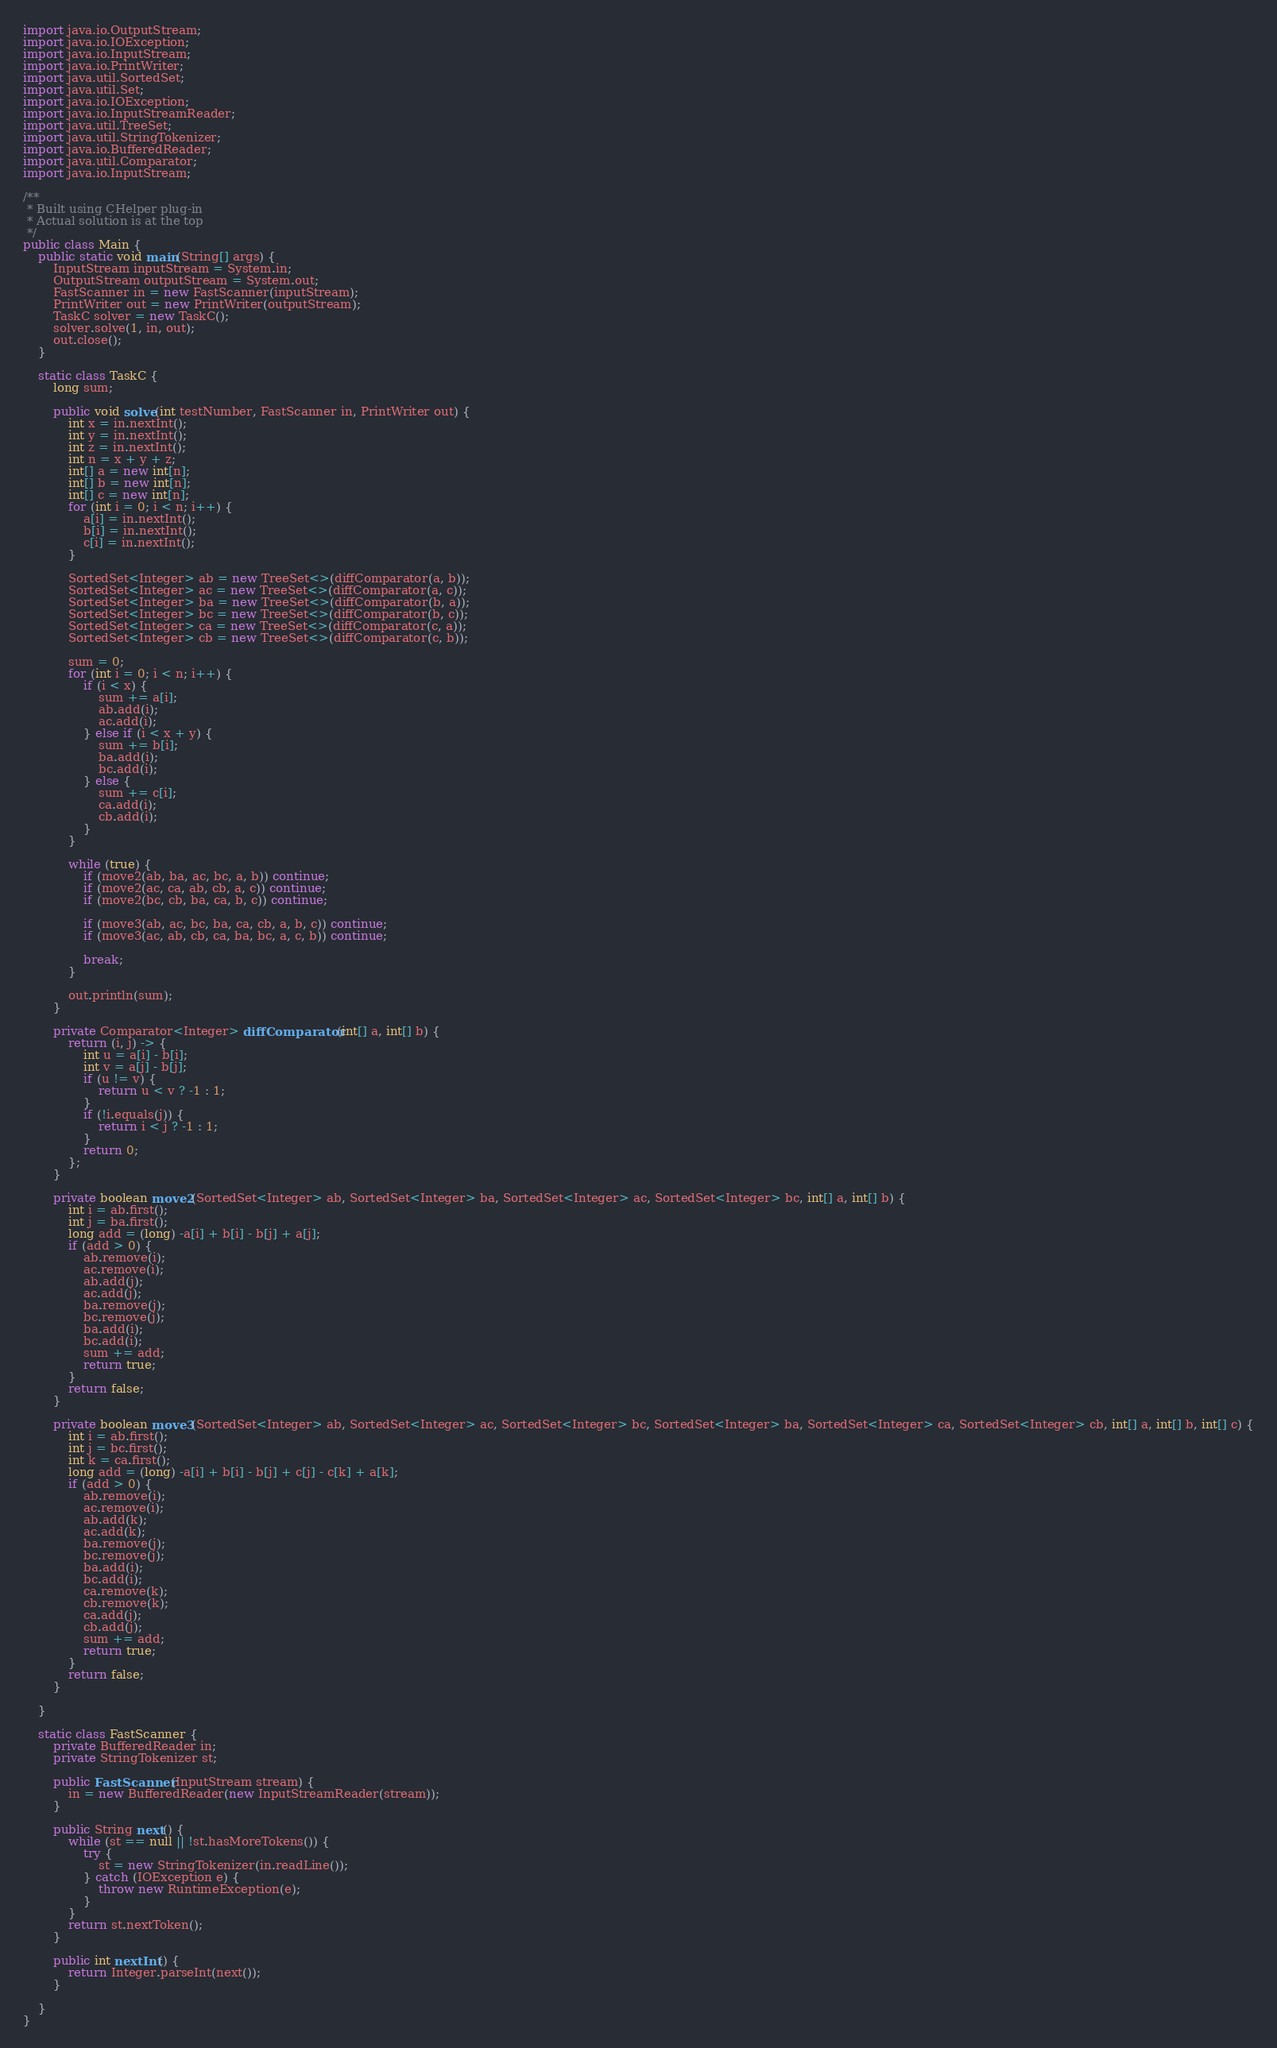<code> <loc_0><loc_0><loc_500><loc_500><_Java_>import java.io.OutputStream;
import java.io.IOException;
import java.io.InputStream;
import java.io.PrintWriter;
import java.util.SortedSet;
import java.util.Set;
import java.io.IOException;
import java.io.InputStreamReader;
import java.util.TreeSet;
import java.util.StringTokenizer;
import java.io.BufferedReader;
import java.util.Comparator;
import java.io.InputStream;

/**
 * Built using CHelper plug-in
 * Actual solution is at the top
 */
public class Main {
	public static void main(String[] args) {
		InputStream inputStream = System.in;
		OutputStream outputStream = System.out;
		FastScanner in = new FastScanner(inputStream);
		PrintWriter out = new PrintWriter(outputStream);
		TaskC solver = new TaskC();
		solver.solve(1, in, out);
		out.close();
	}

	static class TaskC {
		long sum;

		public void solve(int testNumber, FastScanner in, PrintWriter out) {
			int x = in.nextInt();
			int y = in.nextInt();
			int z = in.nextInt();
			int n = x + y + z;
			int[] a = new int[n];
			int[] b = new int[n];
			int[] c = new int[n];
			for (int i = 0; i < n; i++) {
				a[i] = in.nextInt();
				b[i] = in.nextInt();
				c[i] = in.nextInt();
			}

			SortedSet<Integer> ab = new TreeSet<>(diffComparator(a, b));
			SortedSet<Integer> ac = new TreeSet<>(diffComparator(a, c));
			SortedSet<Integer> ba = new TreeSet<>(diffComparator(b, a));
			SortedSet<Integer> bc = new TreeSet<>(diffComparator(b, c));
			SortedSet<Integer> ca = new TreeSet<>(diffComparator(c, a));
			SortedSet<Integer> cb = new TreeSet<>(diffComparator(c, b));

			sum = 0;
			for (int i = 0; i < n; i++) {
				if (i < x) {
					sum += a[i];
					ab.add(i);
					ac.add(i);
				} else if (i < x + y) {
					sum += b[i];
					ba.add(i);
					bc.add(i);
				} else {
					sum += c[i];
					ca.add(i);
					cb.add(i);
				}
			}

			while (true) {
				if (move2(ab, ba, ac, bc, a, b)) continue;
				if (move2(ac, ca, ab, cb, a, c)) continue;
				if (move2(bc, cb, ba, ca, b, c)) continue;

				if (move3(ab, ac, bc, ba, ca, cb, a, b, c)) continue;
				if (move3(ac, ab, cb, ca, ba, bc, a, c, b)) continue;

				break;
			}

			out.println(sum);
		}

		private Comparator<Integer> diffComparator(int[] a, int[] b) {
			return (i, j) -> {
				int u = a[i] - b[i];
				int v = a[j] - b[j];
				if (u != v) {
					return u < v ? -1 : 1;
				}
				if (!i.equals(j)) {
					return i < j ? -1 : 1;
				}
				return 0;
			};
		}

		private boolean move2(SortedSet<Integer> ab, SortedSet<Integer> ba, SortedSet<Integer> ac, SortedSet<Integer> bc, int[] a, int[] b) {
			int i = ab.first();
			int j = ba.first();
			long add = (long) -a[i] + b[i] - b[j] + a[j];
			if (add > 0) {
				ab.remove(i);
				ac.remove(i);
				ab.add(j);
				ac.add(j);
				ba.remove(j);
				bc.remove(j);
				ba.add(i);
				bc.add(i);
				sum += add;
				return true;
			}
			return false;
		}

		private boolean move3(SortedSet<Integer> ab, SortedSet<Integer> ac, SortedSet<Integer> bc, SortedSet<Integer> ba, SortedSet<Integer> ca, SortedSet<Integer> cb, int[] a, int[] b, int[] c) {
			int i = ab.first();
			int j = bc.first();
			int k = ca.first();
			long add = (long) -a[i] + b[i] - b[j] + c[j] - c[k] + a[k];
			if (add > 0) {
				ab.remove(i);
				ac.remove(i);
				ab.add(k);
				ac.add(k);
				ba.remove(j);
				bc.remove(j);
				ba.add(i);
				bc.add(i);
				ca.remove(k);
				cb.remove(k);
				ca.add(j);
				cb.add(j);
				sum += add;
				return true;
			}
			return false;
		}

	}

	static class FastScanner {
		private BufferedReader in;
		private StringTokenizer st;

		public FastScanner(InputStream stream) {
			in = new BufferedReader(new InputStreamReader(stream));
		}

		public String next() {
			while (st == null || !st.hasMoreTokens()) {
				try {
					st = new StringTokenizer(in.readLine());
				} catch (IOException e) {
					throw new RuntimeException(e);
				}
			}
			return st.nextToken();
		}

		public int nextInt() {
			return Integer.parseInt(next());
		}

	}
}

</code> 